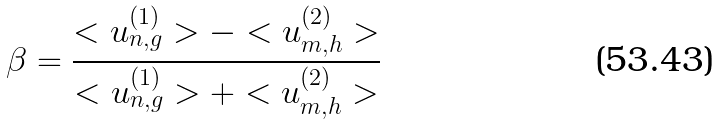<formula> <loc_0><loc_0><loc_500><loc_500>\beta = \frac { < u _ { n , g } ^ { ( 1 ) } > - < u _ { m , h } ^ { ( 2 ) } > } { < u _ { n , g } ^ { ( 1 ) } > + < u _ { m , h } ^ { ( 2 ) } > }</formula> 